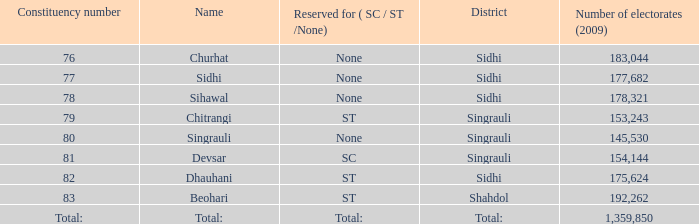What is Beohari's highest number of electorates? 192262.0. 